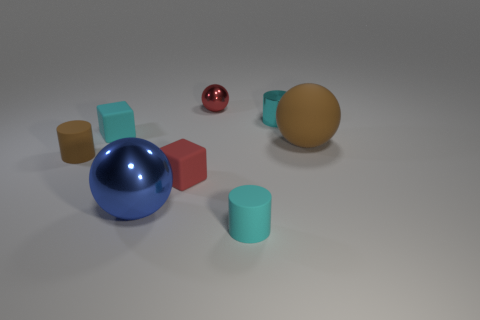Subtract all small cyan metallic cylinders. How many cylinders are left? 2 Add 1 tiny blue objects. How many objects exist? 9 Subtract all cubes. How many objects are left? 6 Add 4 cylinders. How many cylinders are left? 7 Add 1 large purple metal blocks. How many large purple metal blocks exist? 1 Subtract 0 red cylinders. How many objects are left? 8 Subtract all tiny brown cylinders. Subtract all tiny balls. How many objects are left? 6 